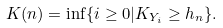<formula> <loc_0><loc_0><loc_500><loc_500>K ( n ) = \inf \{ i \geq 0 | K _ { Y _ { i } } \geq h _ { n } \} .</formula> 